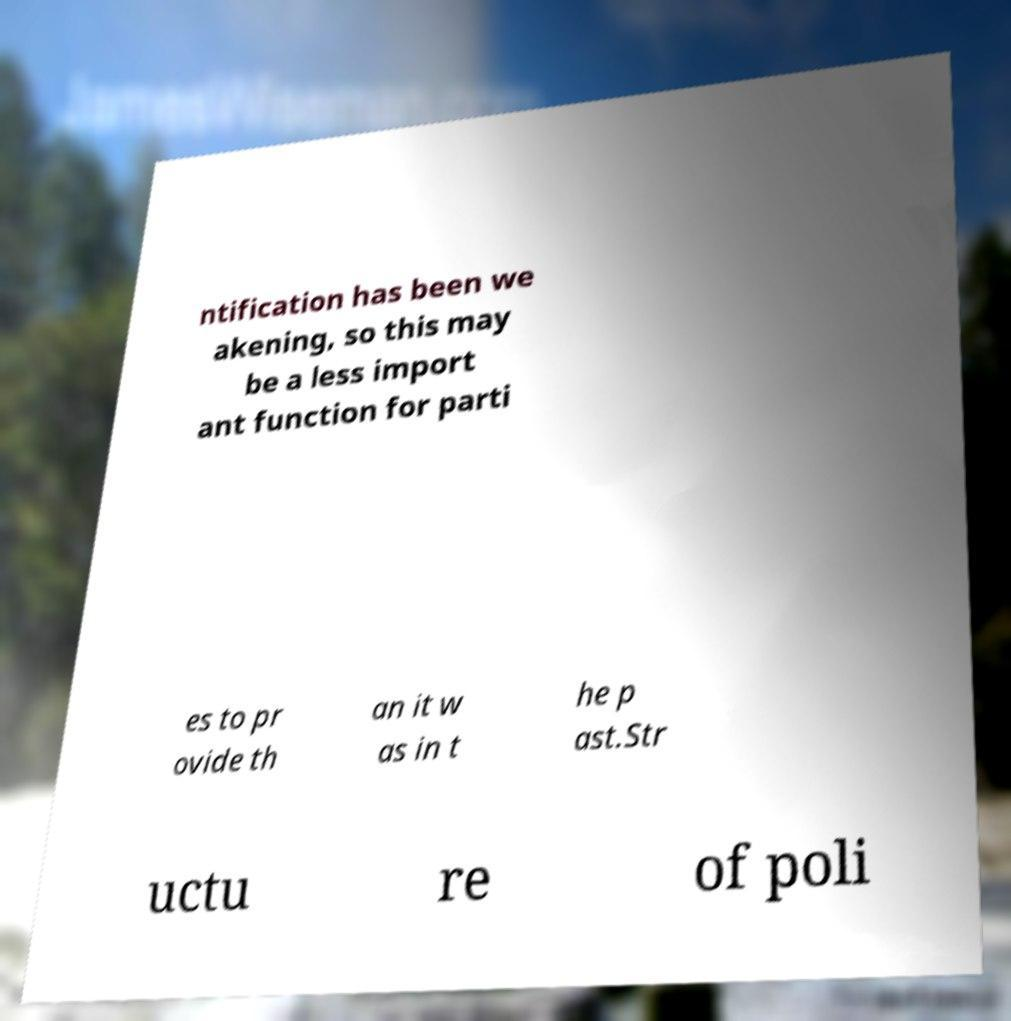Can you read and provide the text displayed in the image?This photo seems to have some interesting text. Can you extract and type it out for me? ntification has been we akening, so this may be a less import ant function for parti es to pr ovide th an it w as in t he p ast.Str uctu re of poli 